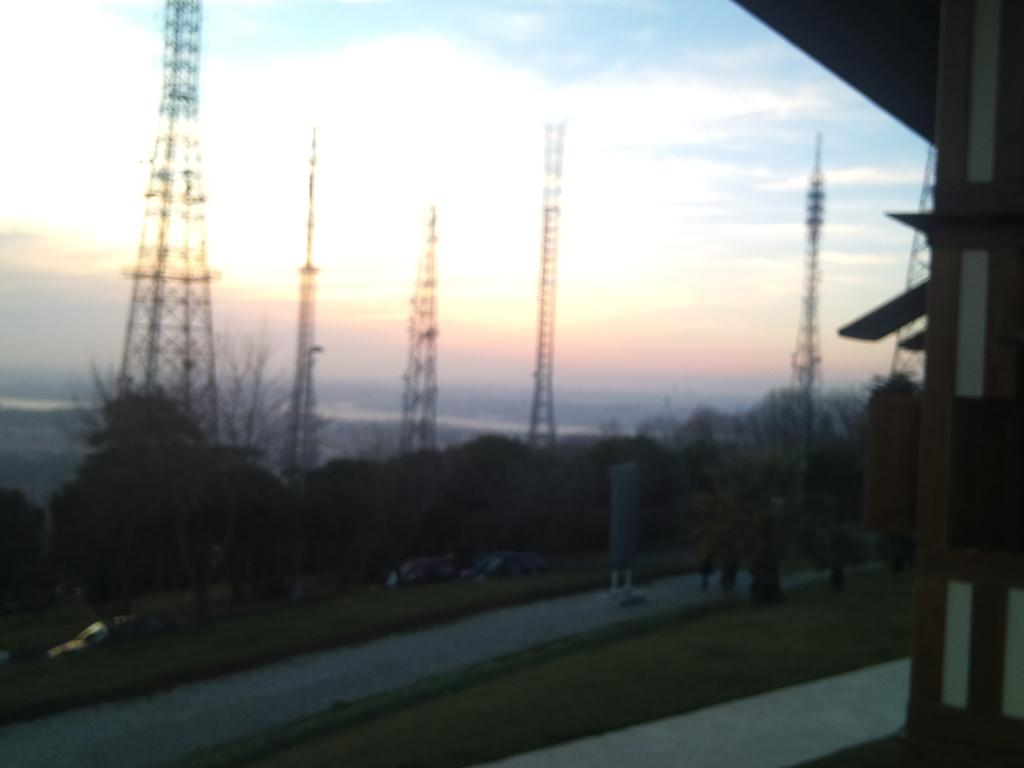What type of natural elements can be seen in the image? There are trees in the image. What type of structures are present in the image? There are towers in the image. What can be used for walking or traveling in the image? There is a path in the image. What else can be seen in the image besides trees and towers? There are some objects in the image. What is visible in the background of the image? The sky is visible in the background of the image. What type of soda is being served in the image? There is no soda present in the image. What color are the trousers worn by the trees in the image? Trees do not wear trousers, as they are natural elements and not human-like beings. 